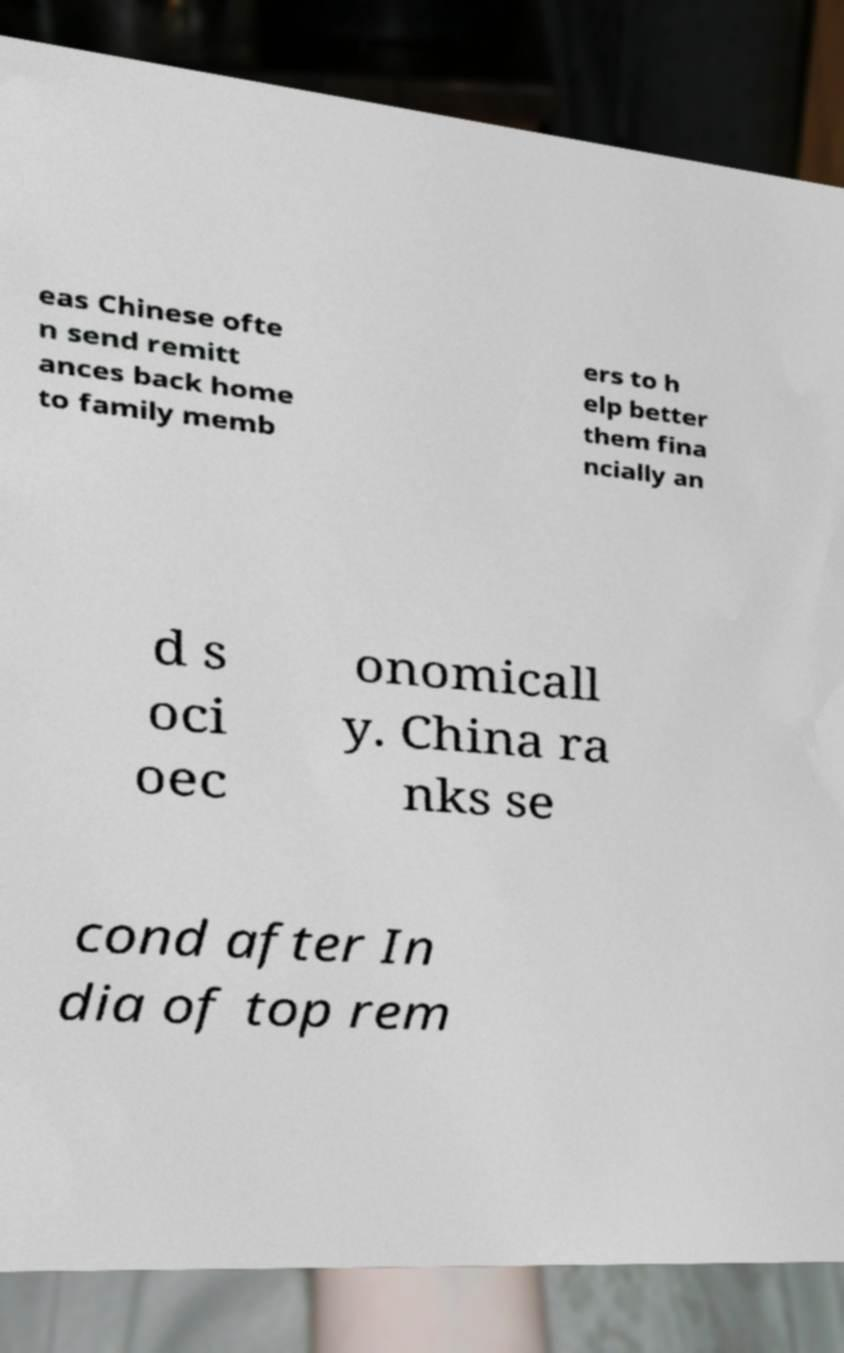Could you extract and type out the text from this image? eas Chinese ofte n send remitt ances back home to family memb ers to h elp better them fina ncially an d s oci oec onomicall y. China ra nks se cond after In dia of top rem 